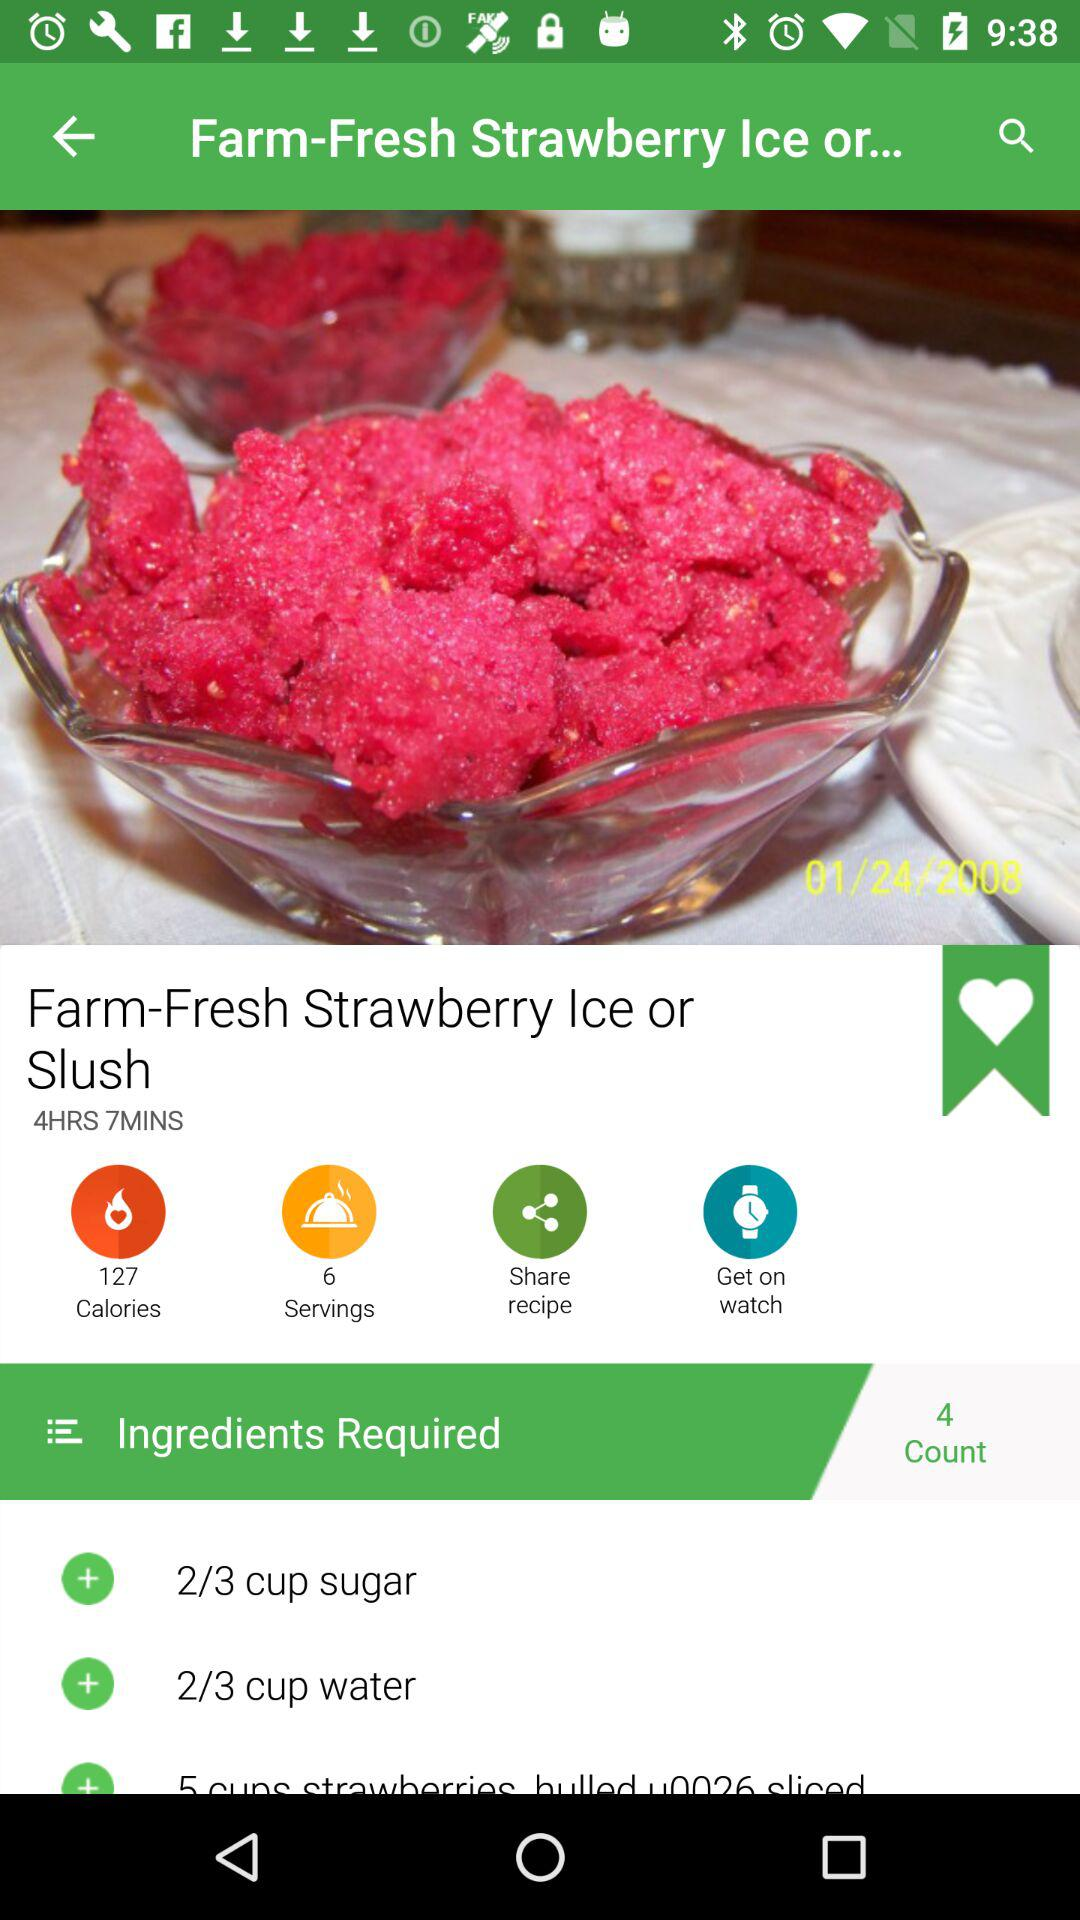How many servings does this recipe make?
Answer the question using a single word or phrase. 6 